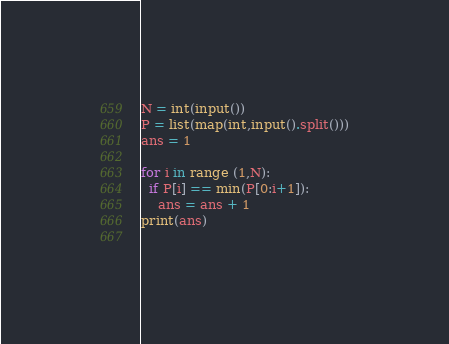Convert code to text. <code><loc_0><loc_0><loc_500><loc_500><_Python_>N = int(input())
P = list(map(int,input().split()))
ans = 1

for i in range (1,N):
  if P[i] == min(P[0:i+1]):
    ans = ans + 1
print(ans)
  </code> 